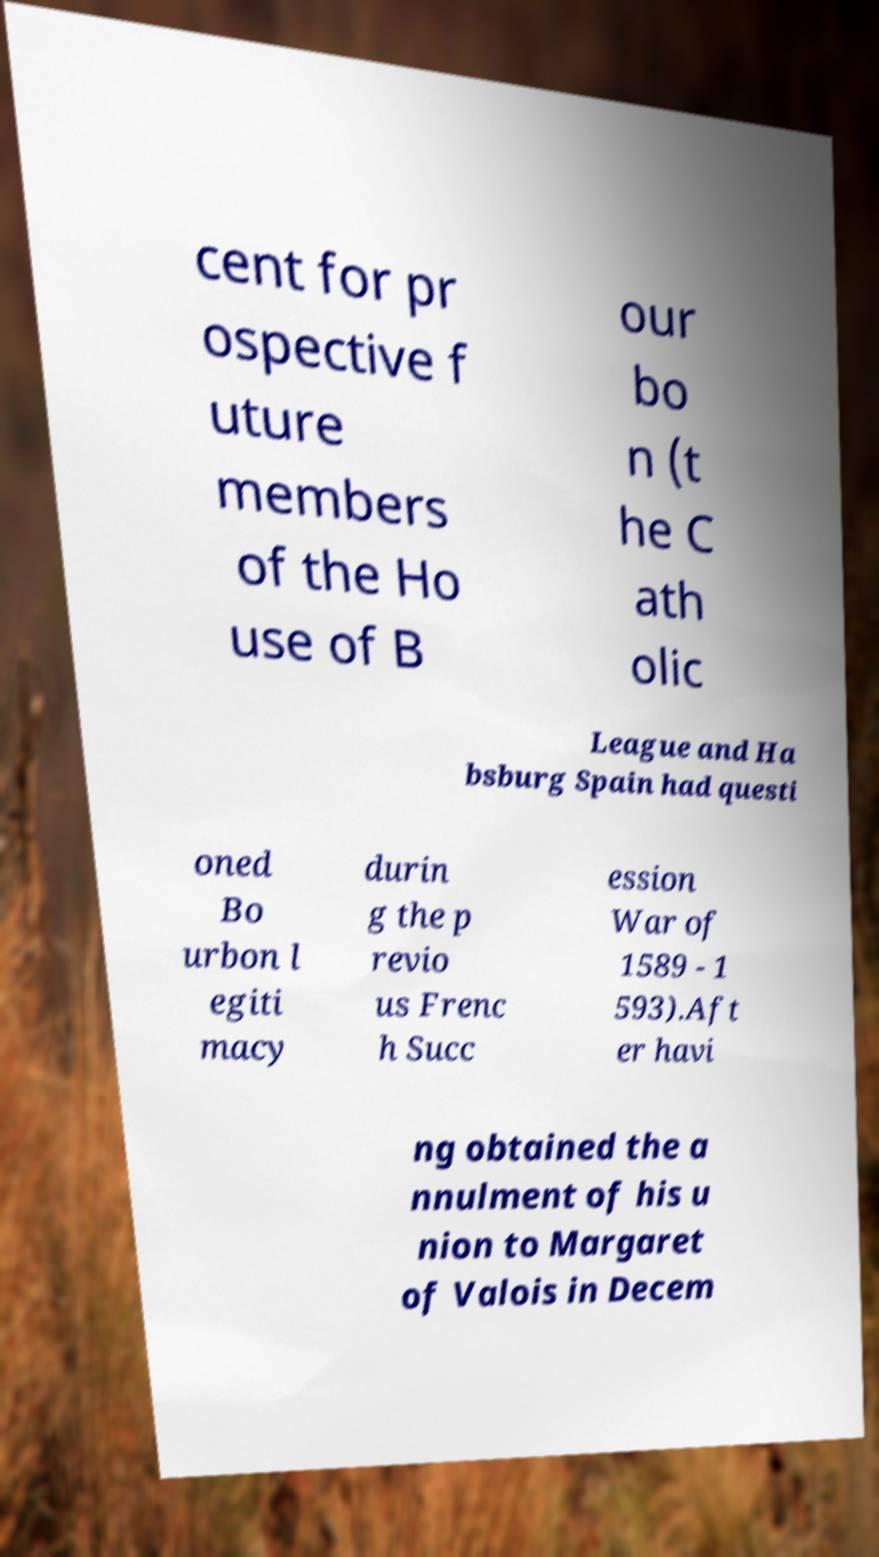Can you read and provide the text displayed in the image?This photo seems to have some interesting text. Can you extract and type it out for me? cent for pr ospective f uture members of the Ho use of B our bo n (t he C ath olic League and Ha bsburg Spain had questi oned Bo urbon l egiti macy durin g the p revio us Frenc h Succ ession War of 1589 - 1 593).Aft er havi ng obtained the a nnulment of his u nion to Margaret of Valois in Decem 